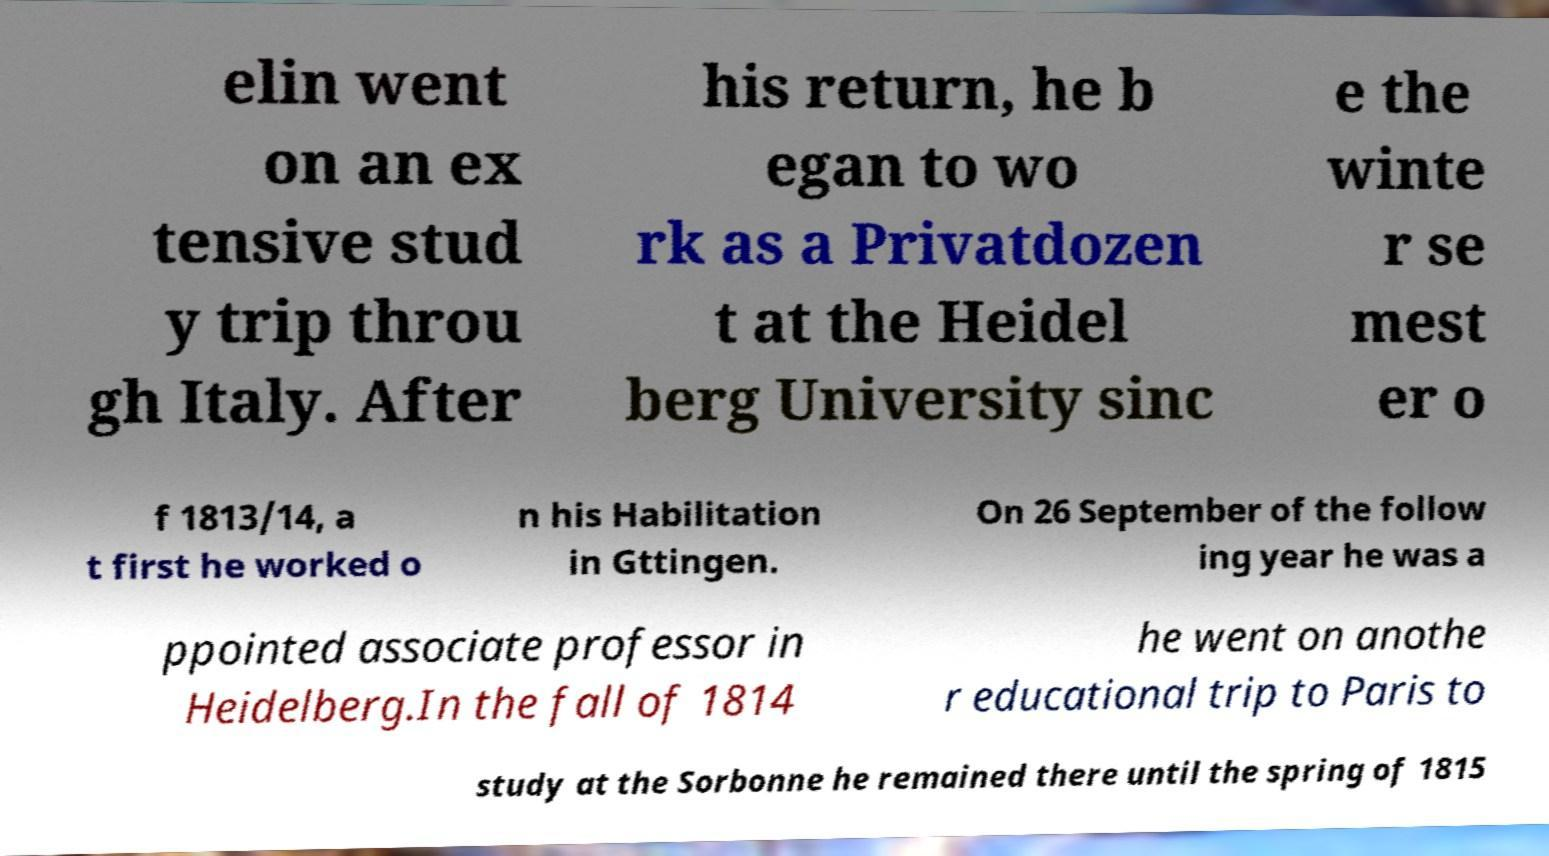Can you read and provide the text displayed in the image?This photo seems to have some interesting text. Can you extract and type it out for me? elin went on an ex tensive stud y trip throu gh Italy. After his return, he b egan to wo rk as a Privatdozen t at the Heidel berg University sinc e the winte r se mest er o f 1813/14, a t first he worked o n his Habilitation in Gttingen. On 26 September of the follow ing year he was a ppointed associate professor in Heidelberg.In the fall of 1814 he went on anothe r educational trip to Paris to study at the Sorbonne he remained there until the spring of 1815 